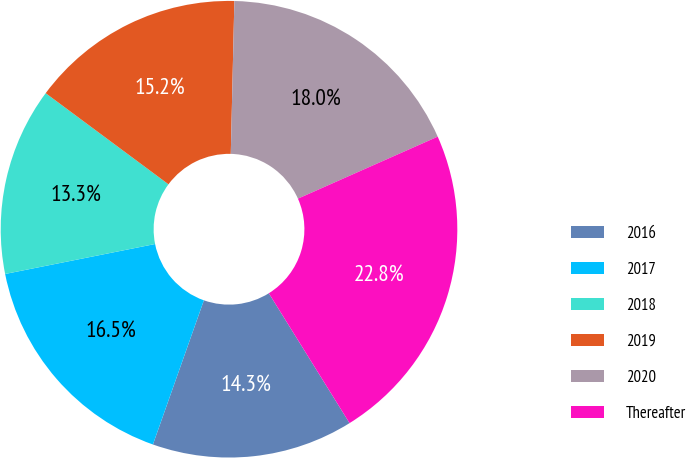Convert chart to OTSL. <chart><loc_0><loc_0><loc_500><loc_500><pie_chart><fcel>2016<fcel>2017<fcel>2018<fcel>2019<fcel>2020<fcel>Thereafter<nl><fcel>14.26%<fcel>16.45%<fcel>13.3%<fcel>15.21%<fcel>17.98%<fcel>22.79%<nl></chart> 